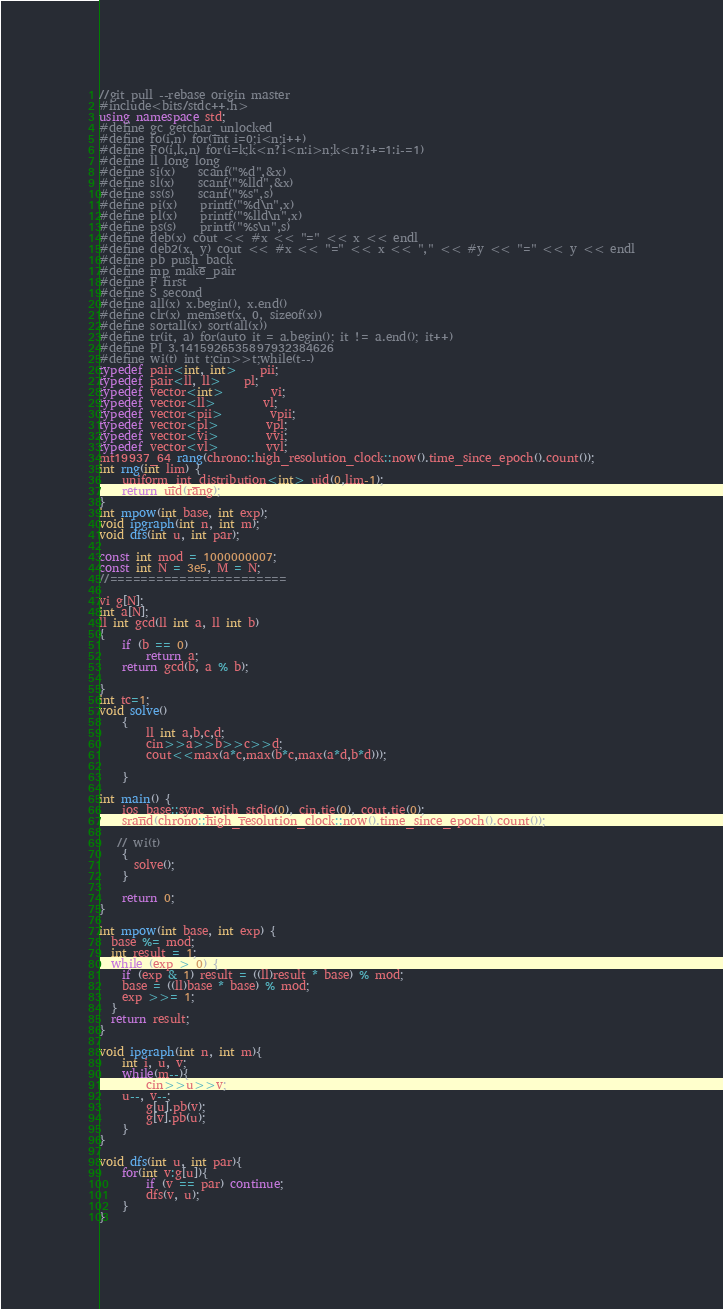Convert code to text. <code><loc_0><loc_0><loc_500><loc_500><_C++_>//git pull --rebase origin master
#include<bits/stdc++.h>
using namespace std;
#define gc getchar_unlocked
#define fo(i,n) for(int i=0;i<n;i++)
#define Fo(i,k,n) for(i=k;k<n?i<n:i>n;k<n?i+=1:i-=1)
#define ll long long
#define si(x)	scanf("%d",&x)
#define sl(x)	scanf("%lld",&x)
#define ss(s)	scanf("%s",s)
#define pi(x)	printf("%d\n",x)
#define pl(x)	printf("%lld\n",x)
#define ps(s)	printf("%s\n",s)
#define deb(x) cout << #x << "=" << x << endl
#define deb2(x, y) cout << #x << "=" << x << "," << #y << "=" << y << endl
#define pb push_back
#define mp make_pair
#define F first
#define S second
#define all(x) x.begin(), x.end()
#define clr(x) memset(x, 0, sizeof(x))
#define sortall(x) sort(all(x))
#define tr(it, a) for(auto it = a.begin(); it != a.end(); it++)
#define PI 3.1415926535897932384626
#define wi(t) int t;cin>>t;while(t--)
typedef pair<int, int>	pii;
typedef pair<ll, ll>	pl;
typedef vector<int>		vi;
typedef vector<ll>		vl;
typedef vector<pii>		vpii;
typedef vector<pl>		vpl;
typedef vector<vi>		vvi;
typedef vector<vl>		vvl;
mt19937_64 rang(chrono::high_resolution_clock::now().time_since_epoch().count());
int rng(int lim) {
    uniform_int_distribution<int> uid(0,lim-1);
    return uid(rang);
}
int mpow(int base, int exp); 
void ipgraph(int n, int m);
void dfs(int u, int par);

const int mod = 1000000007;
const int N = 3e5, M = N;
//=======================

vi g[N];
int a[N];
ll int gcd(ll int a, ll int b) 
{ 
    if (b == 0) 
        return a; 
    return gcd(b, a % b);  
      
} 
int tc=1;
void solve()
    { 
        ll int a,b,c,d;
        cin>>a>>b>>c>>d;
        cout<<max(a*c,max(b*c,max(a*d,b*d)));

    }

int main() {
    ios_base::sync_with_stdio(0), cin.tie(0), cout.tie(0);
    srand(chrono::high_resolution_clock::now().time_since_epoch().count());

   // wi(t)
    {
      solve();
    }

    return 0;
}

int mpow(int base, int exp) {
  base %= mod;
  int result = 1;
  while (exp > 0) {
    if (exp & 1) result = ((ll)result * base) % mod;
    base = ((ll)base * base) % mod;
    exp >>= 1;
  }
  return result;
}

void ipgraph(int n, int m){
    int i, u, v;
    while(m--){
        cin>>u>>v;
    u--, v--;
        g[u].pb(v);
        g[v].pb(u);
    }
}

void dfs(int u, int par){
    for(int v:g[u]){
        if (v == par) continue;
        dfs(v, u);
    }
}





</code> 